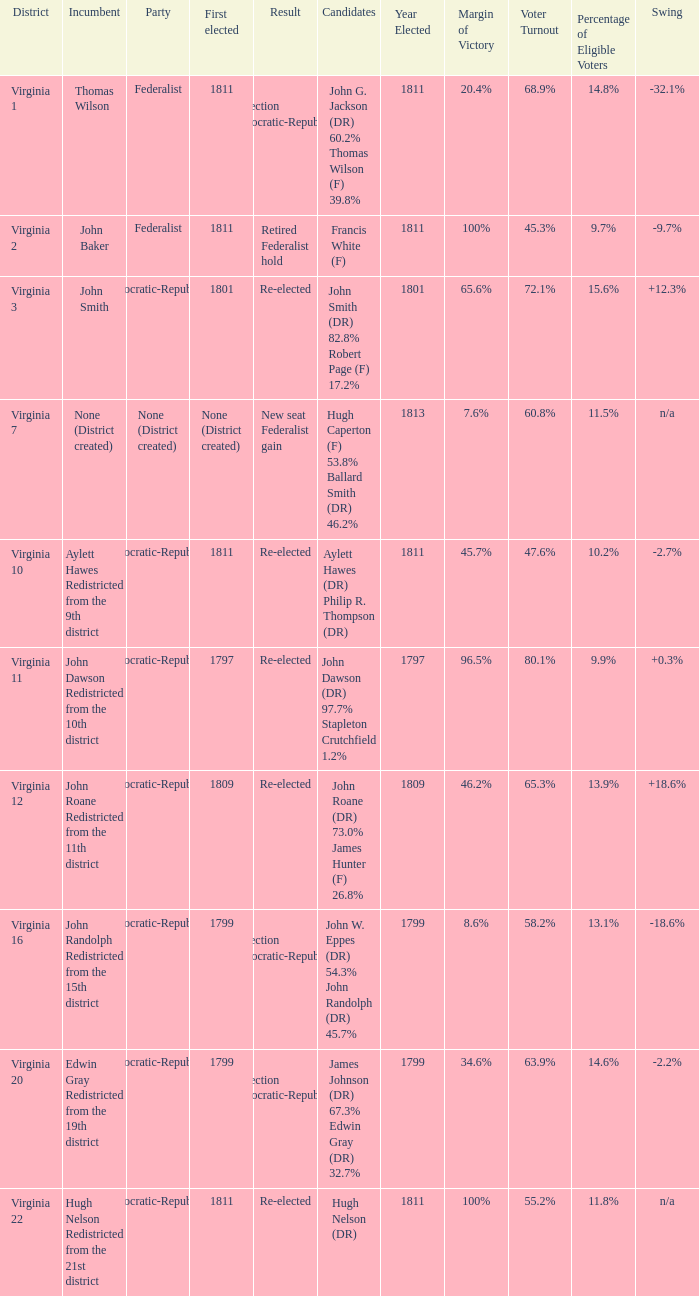Name the party for virginia 12 Democratic-Republican. 